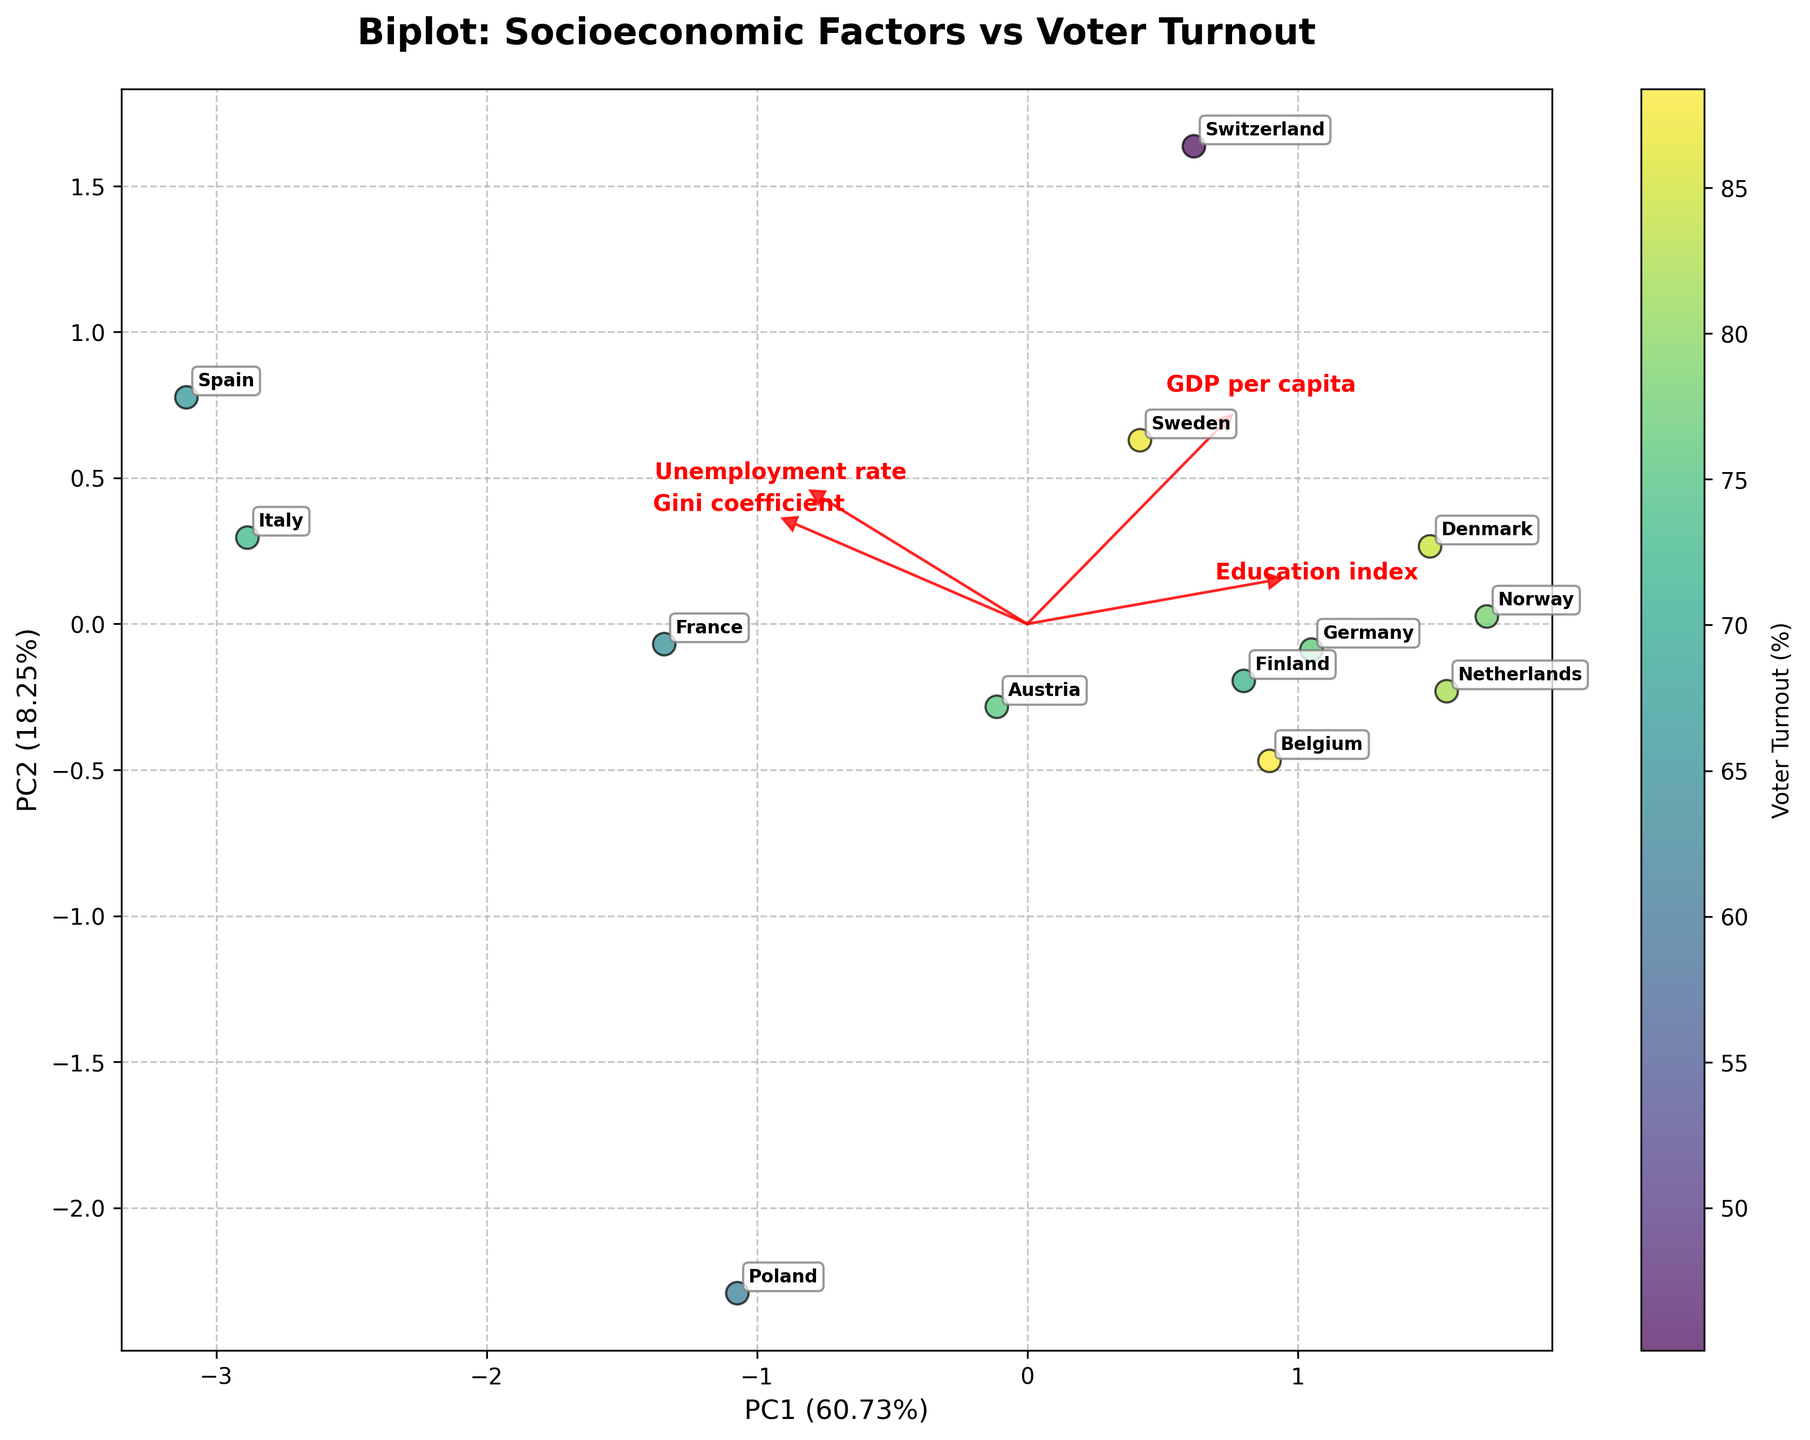What is the title of the figure? The title of the figure is at the top, in bold text.
Answer: Biplot: Socioeconomic Factors vs Voter Turnout How many countries are represented in the figure? To determine the number of countries, count the data points plotted on the graph.
Answer: 12 Which country has the highest voter turnout? The colorbar indicates voter turnout, and the country with the darkest color represents the highest turnout. This can be seen in the annotation of the data point with the darkest color.
Answer: Belgium What do the arrows in the plot represent? The arrows indicate the eigenvectors of the principal components, showing the direction and strength of each socioeconomic factor. This is demonstrated by the red arrows labeled with the respective factors.
Answer: Eigenvectors of the principal components Which socioeconomic factor appears to have the strongest influence on PC1? The length of the arrow in the direction of PC1 indicates the strongest influence. The longer the arrow, the stronger the influence on PC1.
Answer: GDP per capita Are countries with higher GDP per capita more closely associated with higher or lower voter turnout? Look at the scatter plot and the color gradient to determine whether countries with higher GDP per capita (labeled and placed based on PC1) tend to have darker (higher turnout) or lighter (lower turnout) colors.
Answer: Higher voter turnout Which two countries appear closest together on the plot and likely share similar socioeconomic profiles? Examine the relative positions of the annotated data points to identify the two countries closest together.
Answer: Germany and Austria Is there a visible correlation between the unemployment rate and PC2? Observe the direction of the eigenvector associated with the unemployment rate arrow relative to the PC2 axis. If the arrow is pointing more along PC2 than PC1, this indicates a correlation.
Answer: Yes, positive correlation How much of the variance is explained by PC1 and PC2 together? Check the axis labels for PC1 and PC2 to find the explained variance percentages and sum them up.
Answer: 88.13% Which country has the lowest voter turnout, and what might be a contributing socioeconomic factor? The country with the lightest color in the color scale represents the lowest voter turnout. Look at the arrow directions and proximities to infer contributing factors.
Answer: Switzerland, potentially higher GDP per capita 